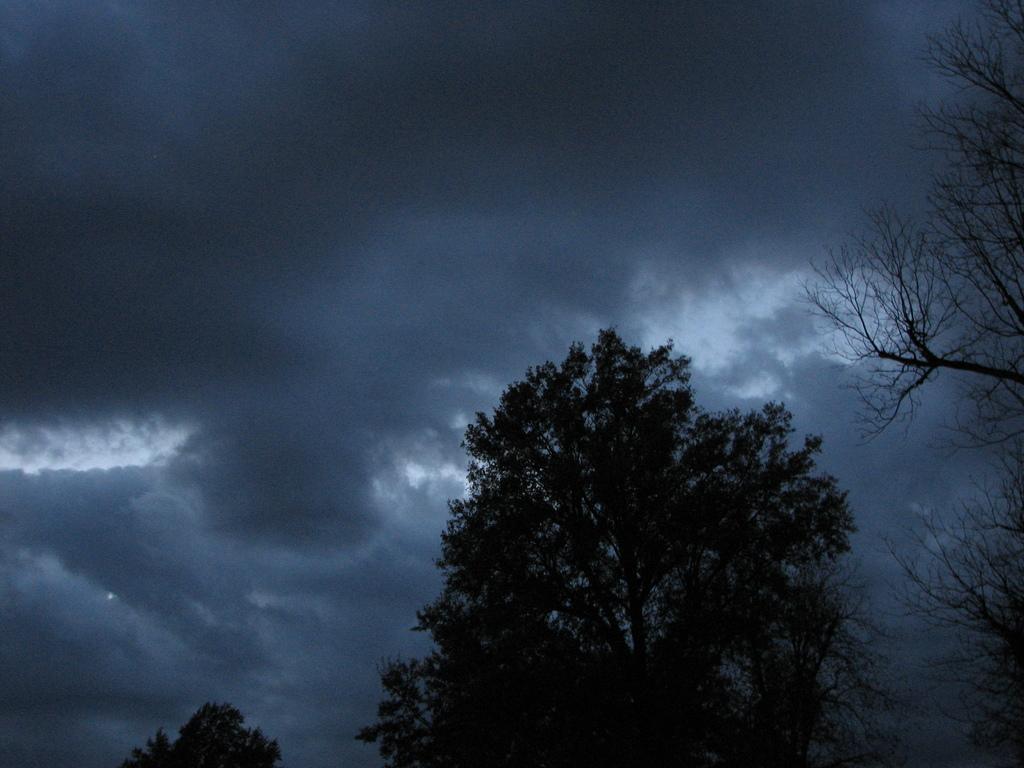Could you give a brief overview of what you see in this image? In the center of the image we can see the trees. In the background of the image we can see the clouds are present in the sky. 